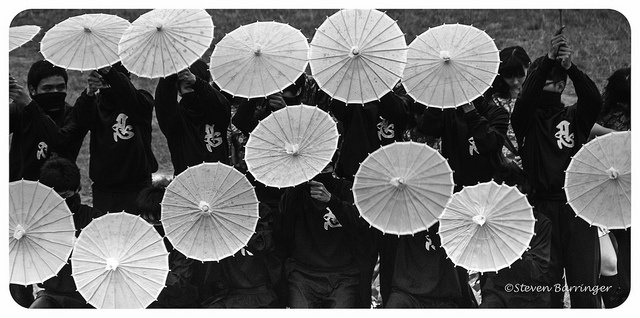Describe the objects in this image and their specific colors. I can see people in white, black, gray, darkgray, and lightgray tones, people in white, black, gray, and darkgray tones, people in white, black, gray, darkgray, and lightgray tones, umbrella in white, lightgray, darkgray, black, and gray tones, and umbrella in white, darkgray, lightgray, gray, and black tones in this image. 